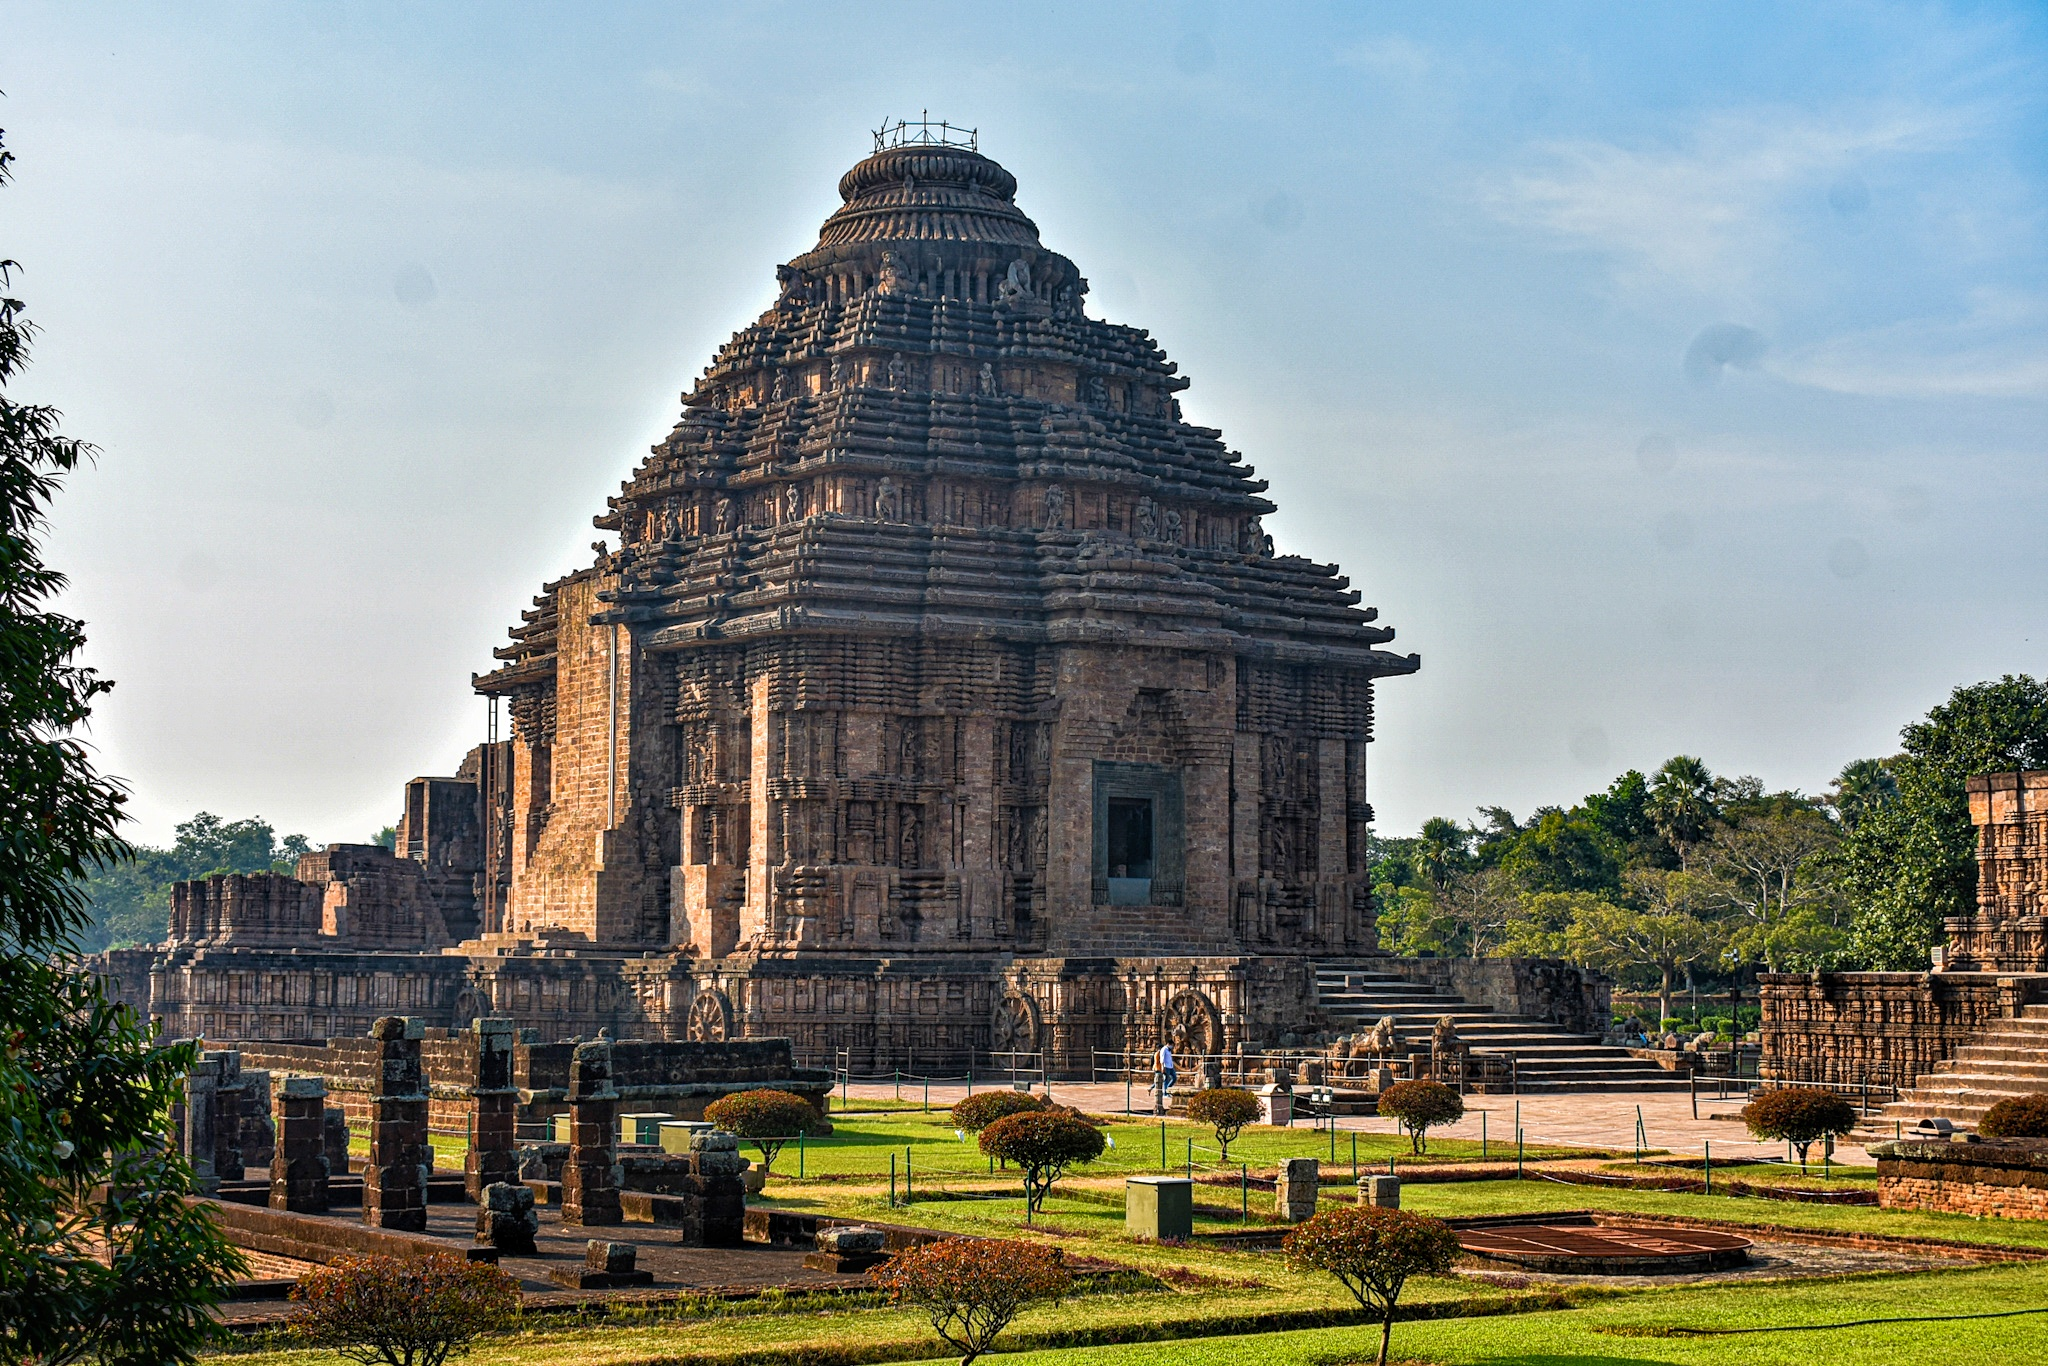What stories do the carvings on the temple walls tell? The exquisite carvings on the walls of the Konark Sun Temple depict a wide array of scenes from ancient Hindu mythology, including the epic tales of the Ramayana and the Mahabharata. These carvings include scenes of battle, courtly processions, and spiritual teachings, serving as a storyboard that provides insights into the religious and cultural life of the period. Additionally, the walls feature dancers, musicians, and mythical creatures, illustrating the everyday and celestial aspects of life. The detail and diversity of these carvings not only adorn the temple but also serve an educational purpose, narrating stories to devotees and visitors through stone. How are these themes represented in the temple's architecture? The architectural elements of the Konark Sun Temple integrate these themes beautifully. Beyond the narrative carvings, the temple’s very structure embodies a cosmic chariot, and the layout of the temple complex mirrors celestial alignments. Architecturally, the temple's orientation and the positioning of the carvings ensure that they interact seamlessly with the sunlight, which illuminates the carvings in a way that brings them to life during specific times of the day. This dynamic interaction between structure, light, and iconography creates a multi-dimensional storytelling medium, making the temple not just a static structure but a living narrative of divine and temporal themes. 